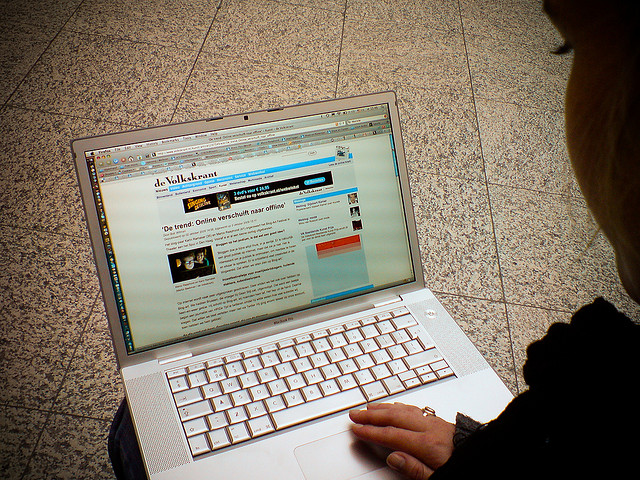<image>What brand of laptop is that? I don't know the brand of the laptop. It can be either HP, Apple, or Dell. What brand of laptop is that? I don't know what brand of laptop it is. It can be HP, Apple, Mac, Dell, or unknown. 